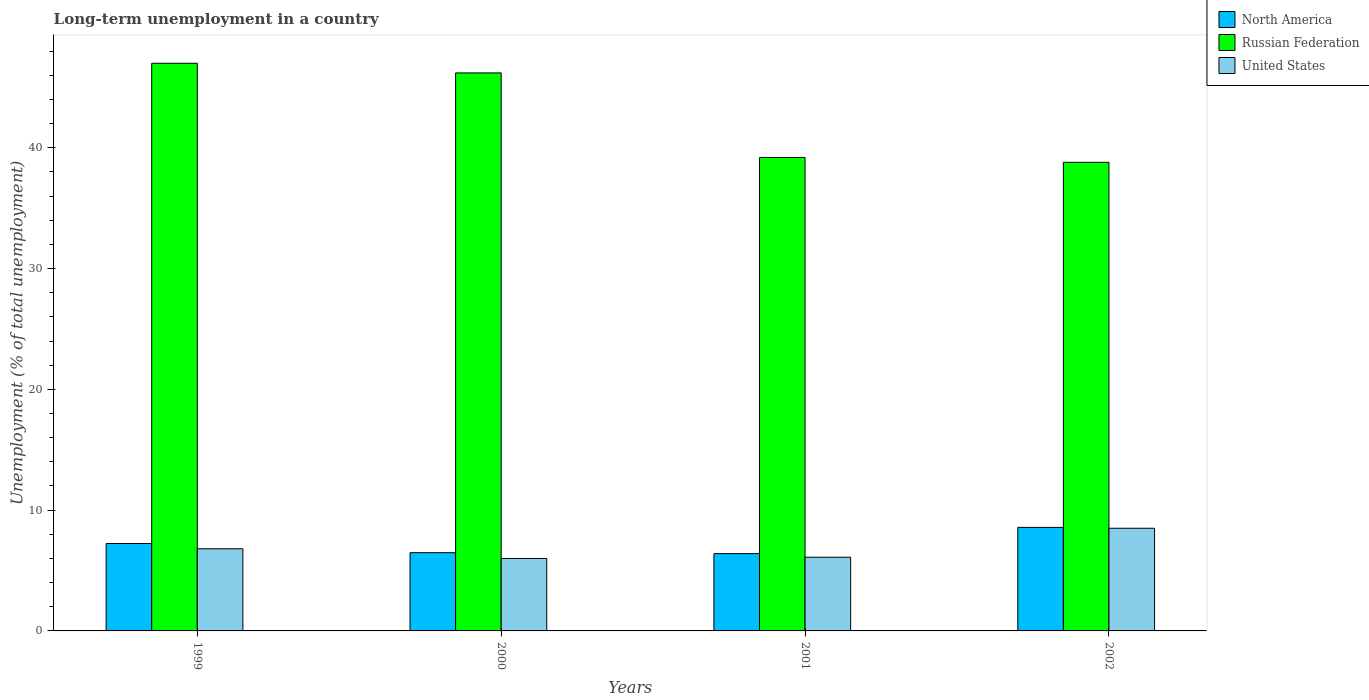How many groups of bars are there?
Your answer should be very brief. 4. Are the number of bars per tick equal to the number of legend labels?
Offer a terse response. Yes. Are the number of bars on each tick of the X-axis equal?
Ensure brevity in your answer.  Yes. What is the label of the 3rd group of bars from the left?
Offer a terse response. 2001. What is the percentage of long-term unemployed population in United States in 2000?
Make the answer very short. 6. Across all years, what is the maximum percentage of long-term unemployed population in United States?
Offer a terse response. 8.5. Across all years, what is the minimum percentage of long-term unemployed population in Russian Federation?
Offer a terse response. 38.8. In which year was the percentage of long-term unemployed population in United States maximum?
Keep it short and to the point. 2002. In which year was the percentage of long-term unemployed population in Russian Federation minimum?
Provide a short and direct response. 2002. What is the total percentage of long-term unemployed population in United States in the graph?
Offer a very short reply. 27.4. What is the difference between the percentage of long-term unemployed population in United States in 2000 and the percentage of long-term unemployed population in Russian Federation in 2001?
Offer a very short reply. -33.2. What is the average percentage of long-term unemployed population in Russian Federation per year?
Ensure brevity in your answer.  42.8. In the year 1999, what is the difference between the percentage of long-term unemployed population in North America and percentage of long-term unemployed population in United States?
Offer a very short reply. 0.44. In how many years, is the percentage of long-term unemployed population in Russian Federation greater than 8 %?
Provide a succinct answer. 4. What is the ratio of the percentage of long-term unemployed population in United States in 2000 to that in 2001?
Make the answer very short. 0.98. Is the percentage of long-term unemployed population in North America in 1999 less than that in 2000?
Provide a short and direct response. No. What is the difference between the highest and the second highest percentage of long-term unemployed population in Russian Federation?
Make the answer very short. 0.8. What is the difference between the highest and the lowest percentage of long-term unemployed population in Russian Federation?
Offer a very short reply. 8.2. In how many years, is the percentage of long-term unemployed population in North America greater than the average percentage of long-term unemployed population in North America taken over all years?
Offer a very short reply. 2. What does the 2nd bar from the right in 1999 represents?
Keep it short and to the point. Russian Federation. How many bars are there?
Your response must be concise. 12. How many years are there in the graph?
Provide a short and direct response. 4. What is the difference between two consecutive major ticks on the Y-axis?
Your response must be concise. 10. Are the values on the major ticks of Y-axis written in scientific E-notation?
Your answer should be very brief. No. Does the graph contain any zero values?
Offer a very short reply. No. Does the graph contain grids?
Provide a short and direct response. No. Where does the legend appear in the graph?
Your answer should be very brief. Top right. How many legend labels are there?
Give a very brief answer. 3. What is the title of the graph?
Provide a short and direct response. Long-term unemployment in a country. What is the label or title of the Y-axis?
Keep it short and to the point. Unemployment (% of total unemployment). What is the Unemployment (% of total unemployment) of North America in 1999?
Provide a short and direct response. 7.24. What is the Unemployment (% of total unemployment) in Russian Federation in 1999?
Offer a terse response. 47. What is the Unemployment (% of total unemployment) in United States in 1999?
Keep it short and to the point. 6.8. What is the Unemployment (% of total unemployment) in North America in 2000?
Provide a short and direct response. 6.48. What is the Unemployment (% of total unemployment) of Russian Federation in 2000?
Keep it short and to the point. 46.2. What is the Unemployment (% of total unemployment) of North America in 2001?
Your answer should be compact. 6.4. What is the Unemployment (% of total unemployment) of Russian Federation in 2001?
Give a very brief answer. 39.2. What is the Unemployment (% of total unemployment) of United States in 2001?
Your answer should be very brief. 6.1. What is the Unemployment (% of total unemployment) of North America in 2002?
Your response must be concise. 8.57. What is the Unemployment (% of total unemployment) of Russian Federation in 2002?
Offer a very short reply. 38.8. What is the Unemployment (% of total unemployment) of United States in 2002?
Provide a short and direct response. 8.5. Across all years, what is the maximum Unemployment (% of total unemployment) in North America?
Make the answer very short. 8.57. Across all years, what is the maximum Unemployment (% of total unemployment) in Russian Federation?
Provide a short and direct response. 47. Across all years, what is the minimum Unemployment (% of total unemployment) in North America?
Your response must be concise. 6.4. Across all years, what is the minimum Unemployment (% of total unemployment) of Russian Federation?
Keep it short and to the point. 38.8. Across all years, what is the minimum Unemployment (% of total unemployment) of United States?
Provide a succinct answer. 6. What is the total Unemployment (% of total unemployment) of North America in the graph?
Your response must be concise. 28.68. What is the total Unemployment (% of total unemployment) of Russian Federation in the graph?
Offer a very short reply. 171.2. What is the total Unemployment (% of total unemployment) in United States in the graph?
Provide a short and direct response. 27.4. What is the difference between the Unemployment (% of total unemployment) of North America in 1999 and that in 2000?
Make the answer very short. 0.76. What is the difference between the Unemployment (% of total unemployment) of North America in 1999 and that in 2001?
Offer a very short reply. 0.84. What is the difference between the Unemployment (% of total unemployment) of North America in 1999 and that in 2002?
Keep it short and to the point. -1.34. What is the difference between the Unemployment (% of total unemployment) of North America in 2000 and that in 2001?
Make the answer very short. 0.08. What is the difference between the Unemployment (% of total unemployment) in North America in 2000 and that in 2002?
Give a very brief answer. -2.09. What is the difference between the Unemployment (% of total unemployment) of Russian Federation in 2000 and that in 2002?
Your response must be concise. 7.4. What is the difference between the Unemployment (% of total unemployment) in United States in 2000 and that in 2002?
Offer a terse response. -2.5. What is the difference between the Unemployment (% of total unemployment) in North America in 2001 and that in 2002?
Ensure brevity in your answer.  -2.17. What is the difference between the Unemployment (% of total unemployment) in Russian Federation in 2001 and that in 2002?
Provide a short and direct response. 0.4. What is the difference between the Unemployment (% of total unemployment) in North America in 1999 and the Unemployment (% of total unemployment) in Russian Federation in 2000?
Give a very brief answer. -38.96. What is the difference between the Unemployment (% of total unemployment) in North America in 1999 and the Unemployment (% of total unemployment) in United States in 2000?
Ensure brevity in your answer.  1.24. What is the difference between the Unemployment (% of total unemployment) of North America in 1999 and the Unemployment (% of total unemployment) of Russian Federation in 2001?
Offer a very short reply. -31.96. What is the difference between the Unemployment (% of total unemployment) of North America in 1999 and the Unemployment (% of total unemployment) of United States in 2001?
Offer a terse response. 1.14. What is the difference between the Unemployment (% of total unemployment) of Russian Federation in 1999 and the Unemployment (% of total unemployment) of United States in 2001?
Your answer should be compact. 40.9. What is the difference between the Unemployment (% of total unemployment) of North America in 1999 and the Unemployment (% of total unemployment) of Russian Federation in 2002?
Offer a very short reply. -31.56. What is the difference between the Unemployment (% of total unemployment) of North America in 1999 and the Unemployment (% of total unemployment) of United States in 2002?
Make the answer very short. -1.26. What is the difference between the Unemployment (% of total unemployment) in Russian Federation in 1999 and the Unemployment (% of total unemployment) in United States in 2002?
Your answer should be compact. 38.5. What is the difference between the Unemployment (% of total unemployment) of North America in 2000 and the Unemployment (% of total unemployment) of Russian Federation in 2001?
Keep it short and to the point. -32.72. What is the difference between the Unemployment (% of total unemployment) of North America in 2000 and the Unemployment (% of total unemployment) of United States in 2001?
Offer a very short reply. 0.38. What is the difference between the Unemployment (% of total unemployment) of Russian Federation in 2000 and the Unemployment (% of total unemployment) of United States in 2001?
Keep it short and to the point. 40.1. What is the difference between the Unemployment (% of total unemployment) of North America in 2000 and the Unemployment (% of total unemployment) of Russian Federation in 2002?
Ensure brevity in your answer.  -32.32. What is the difference between the Unemployment (% of total unemployment) of North America in 2000 and the Unemployment (% of total unemployment) of United States in 2002?
Provide a short and direct response. -2.02. What is the difference between the Unemployment (% of total unemployment) of Russian Federation in 2000 and the Unemployment (% of total unemployment) of United States in 2002?
Your answer should be very brief. 37.7. What is the difference between the Unemployment (% of total unemployment) of North America in 2001 and the Unemployment (% of total unemployment) of Russian Federation in 2002?
Provide a short and direct response. -32.4. What is the difference between the Unemployment (% of total unemployment) in North America in 2001 and the Unemployment (% of total unemployment) in United States in 2002?
Your answer should be compact. -2.1. What is the difference between the Unemployment (% of total unemployment) in Russian Federation in 2001 and the Unemployment (% of total unemployment) in United States in 2002?
Offer a terse response. 30.7. What is the average Unemployment (% of total unemployment) of North America per year?
Your response must be concise. 7.17. What is the average Unemployment (% of total unemployment) of Russian Federation per year?
Offer a very short reply. 42.8. What is the average Unemployment (% of total unemployment) in United States per year?
Offer a terse response. 6.85. In the year 1999, what is the difference between the Unemployment (% of total unemployment) in North America and Unemployment (% of total unemployment) in Russian Federation?
Your response must be concise. -39.76. In the year 1999, what is the difference between the Unemployment (% of total unemployment) in North America and Unemployment (% of total unemployment) in United States?
Keep it short and to the point. 0.44. In the year 1999, what is the difference between the Unemployment (% of total unemployment) of Russian Federation and Unemployment (% of total unemployment) of United States?
Make the answer very short. 40.2. In the year 2000, what is the difference between the Unemployment (% of total unemployment) in North America and Unemployment (% of total unemployment) in Russian Federation?
Make the answer very short. -39.72. In the year 2000, what is the difference between the Unemployment (% of total unemployment) of North America and Unemployment (% of total unemployment) of United States?
Give a very brief answer. 0.48. In the year 2000, what is the difference between the Unemployment (% of total unemployment) of Russian Federation and Unemployment (% of total unemployment) of United States?
Give a very brief answer. 40.2. In the year 2001, what is the difference between the Unemployment (% of total unemployment) in North America and Unemployment (% of total unemployment) in Russian Federation?
Your answer should be compact. -32.8. In the year 2001, what is the difference between the Unemployment (% of total unemployment) of North America and Unemployment (% of total unemployment) of United States?
Offer a very short reply. 0.3. In the year 2001, what is the difference between the Unemployment (% of total unemployment) of Russian Federation and Unemployment (% of total unemployment) of United States?
Your answer should be compact. 33.1. In the year 2002, what is the difference between the Unemployment (% of total unemployment) of North America and Unemployment (% of total unemployment) of Russian Federation?
Make the answer very short. -30.23. In the year 2002, what is the difference between the Unemployment (% of total unemployment) of North America and Unemployment (% of total unemployment) of United States?
Make the answer very short. 0.07. In the year 2002, what is the difference between the Unemployment (% of total unemployment) in Russian Federation and Unemployment (% of total unemployment) in United States?
Provide a succinct answer. 30.3. What is the ratio of the Unemployment (% of total unemployment) of North America in 1999 to that in 2000?
Provide a short and direct response. 1.12. What is the ratio of the Unemployment (% of total unemployment) in Russian Federation in 1999 to that in 2000?
Provide a succinct answer. 1.02. What is the ratio of the Unemployment (% of total unemployment) in United States in 1999 to that in 2000?
Offer a very short reply. 1.13. What is the ratio of the Unemployment (% of total unemployment) of North America in 1999 to that in 2001?
Make the answer very short. 1.13. What is the ratio of the Unemployment (% of total unemployment) of Russian Federation in 1999 to that in 2001?
Your response must be concise. 1.2. What is the ratio of the Unemployment (% of total unemployment) of United States in 1999 to that in 2001?
Give a very brief answer. 1.11. What is the ratio of the Unemployment (% of total unemployment) in North America in 1999 to that in 2002?
Provide a short and direct response. 0.84. What is the ratio of the Unemployment (% of total unemployment) in Russian Federation in 1999 to that in 2002?
Make the answer very short. 1.21. What is the ratio of the Unemployment (% of total unemployment) in Russian Federation in 2000 to that in 2001?
Make the answer very short. 1.18. What is the ratio of the Unemployment (% of total unemployment) of United States in 2000 to that in 2001?
Give a very brief answer. 0.98. What is the ratio of the Unemployment (% of total unemployment) of North America in 2000 to that in 2002?
Provide a succinct answer. 0.76. What is the ratio of the Unemployment (% of total unemployment) in Russian Federation in 2000 to that in 2002?
Offer a very short reply. 1.19. What is the ratio of the Unemployment (% of total unemployment) in United States in 2000 to that in 2002?
Your answer should be very brief. 0.71. What is the ratio of the Unemployment (% of total unemployment) of North America in 2001 to that in 2002?
Ensure brevity in your answer.  0.75. What is the ratio of the Unemployment (% of total unemployment) in Russian Federation in 2001 to that in 2002?
Make the answer very short. 1.01. What is the ratio of the Unemployment (% of total unemployment) in United States in 2001 to that in 2002?
Provide a succinct answer. 0.72. What is the difference between the highest and the second highest Unemployment (% of total unemployment) in North America?
Offer a terse response. 1.34. What is the difference between the highest and the second highest Unemployment (% of total unemployment) of Russian Federation?
Your answer should be very brief. 0.8. What is the difference between the highest and the second highest Unemployment (% of total unemployment) in United States?
Your answer should be very brief. 1.7. What is the difference between the highest and the lowest Unemployment (% of total unemployment) of North America?
Your answer should be very brief. 2.17. What is the difference between the highest and the lowest Unemployment (% of total unemployment) in Russian Federation?
Offer a terse response. 8.2. What is the difference between the highest and the lowest Unemployment (% of total unemployment) of United States?
Ensure brevity in your answer.  2.5. 